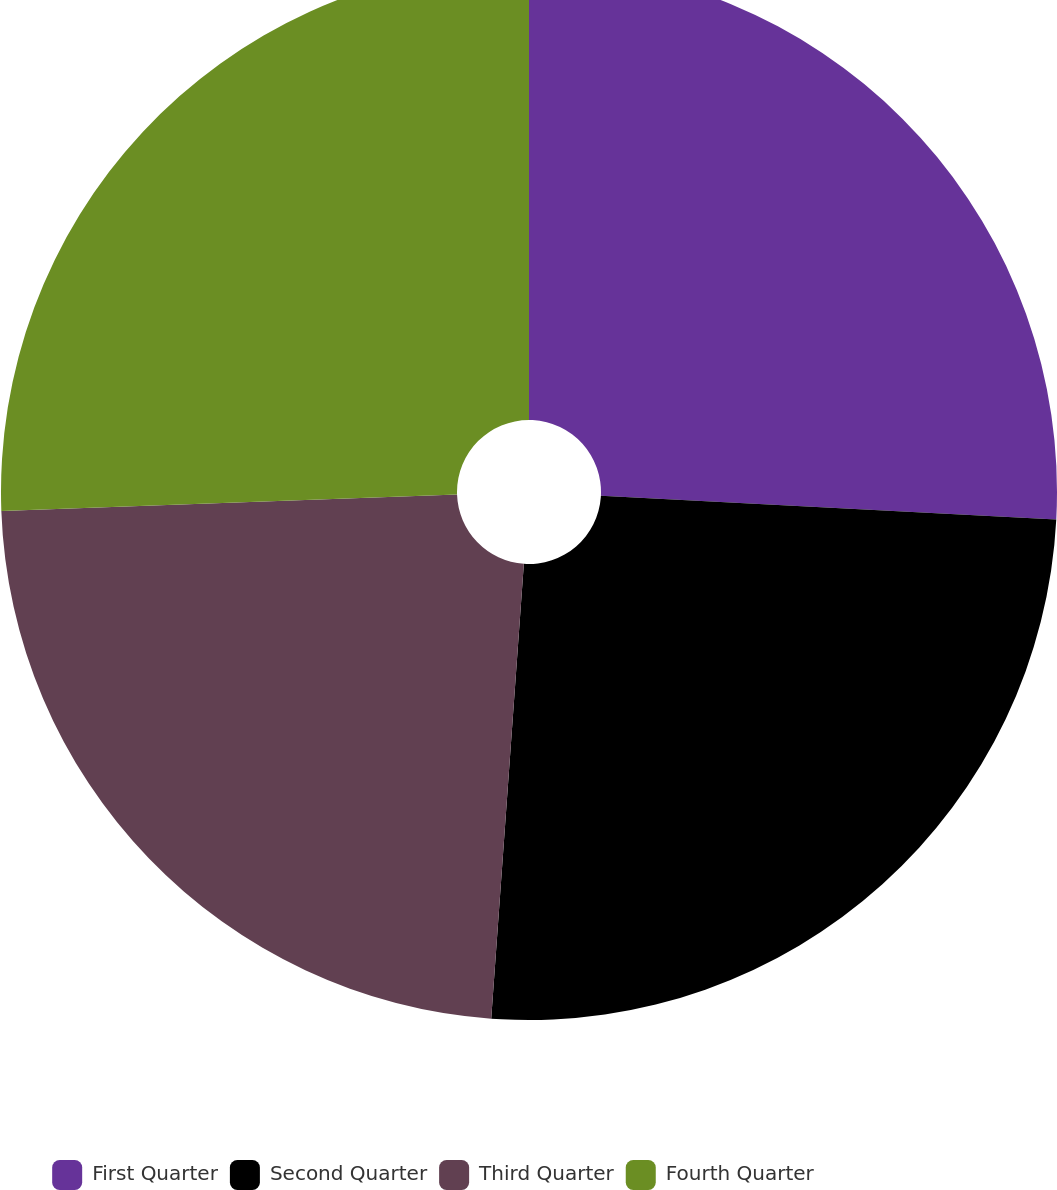Convert chart to OTSL. <chart><loc_0><loc_0><loc_500><loc_500><pie_chart><fcel>First Quarter<fcel>Second Quarter<fcel>Third Quarter<fcel>Fourth Quarter<nl><fcel>25.83%<fcel>25.31%<fcel>23.29%<fcel>25.57%<nl></chart> 